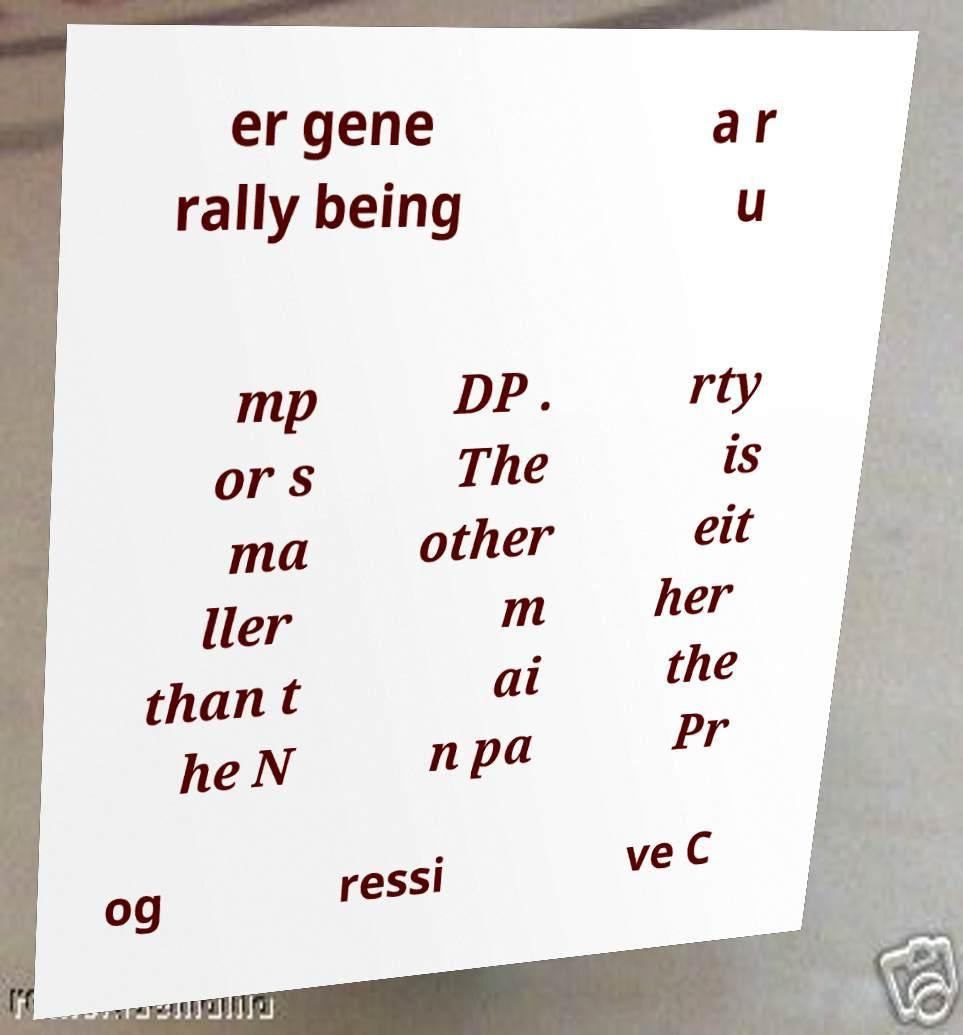Can you read and provide the text displayed in the image?This photo seems to have some interesting text. Can you extract and type it out for me? er gene rally being a r u mp or s ma ller than t he N DP . The other m ai n pa rty is eit her the Pr og ressi ve C 